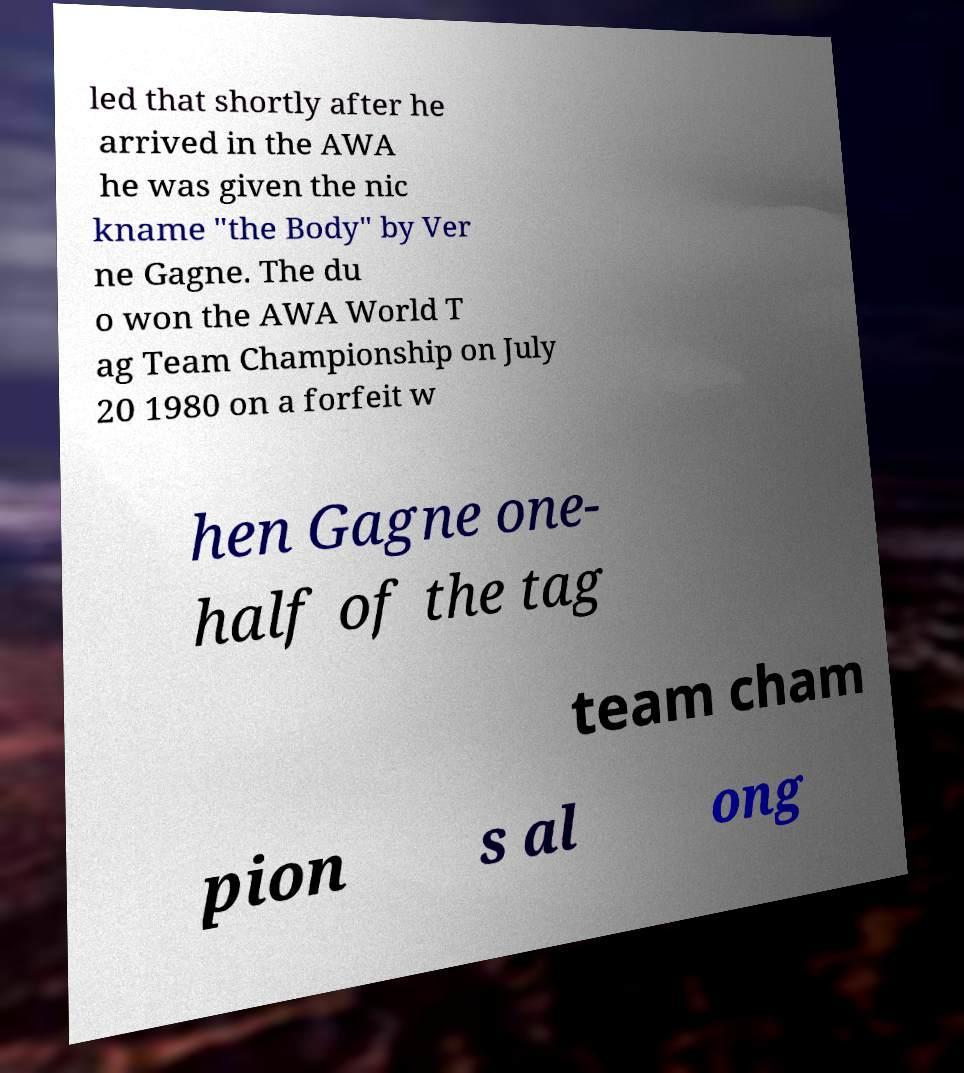I need the written content from this picture converted into text. Can you do that? led that shortly after he arrived in the AWA he was given the nic kname "the Body" by Ver ne Gagne. The du o won the AWA World T ag Team Championship on July 20 1980 on a forfeit w hen Gagne one- half of the tag team cham pion s al ong 